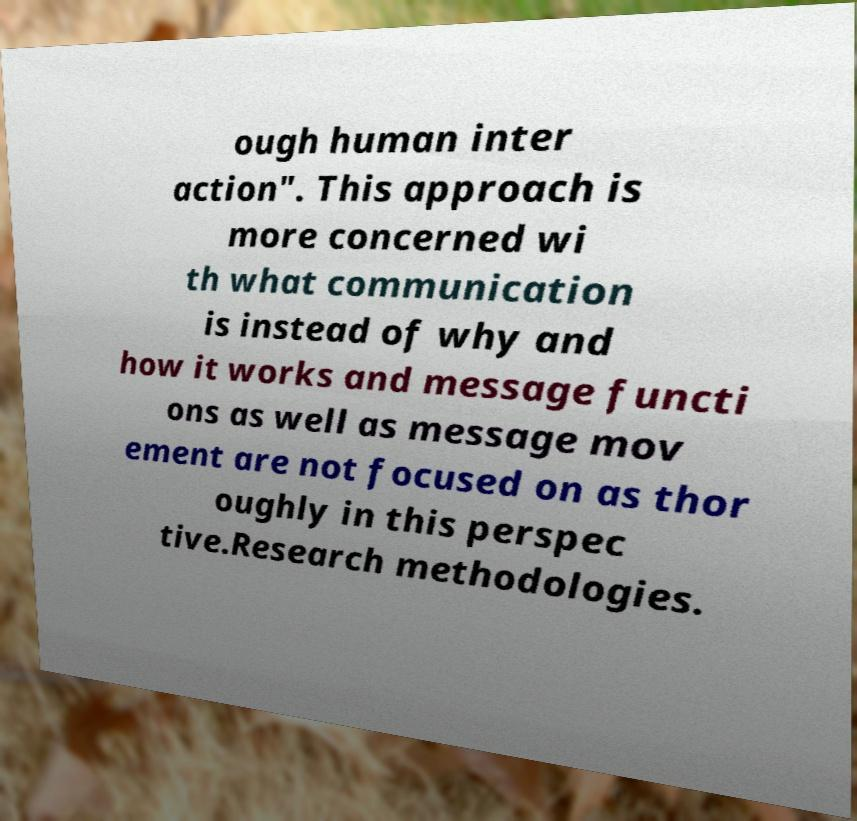Could you extract and type out the text from this image? ough human inter action". This approach is more concerned wi th what communication is instead of why and how it works and message functi ons as well as message mov ement are not focused on as thor oughly in this perspec tive.Research methodologies. 